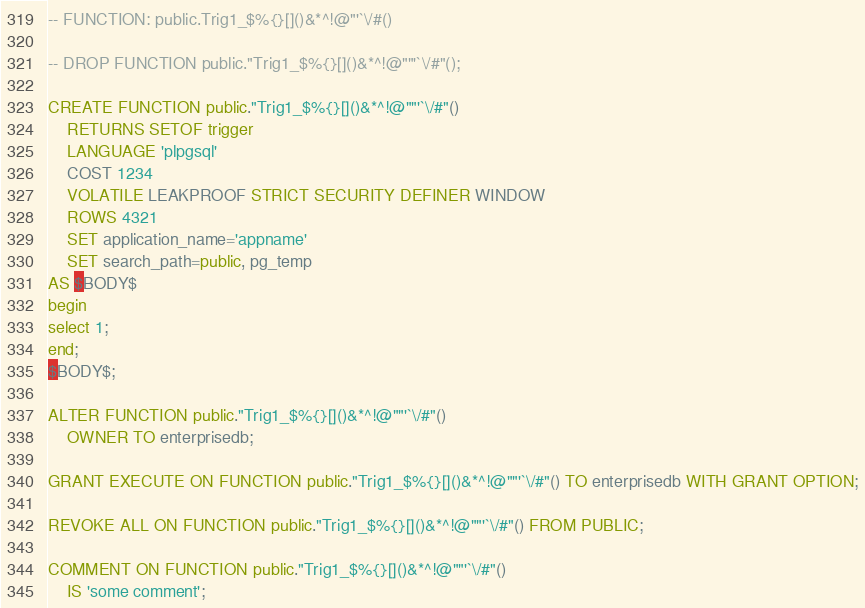<code> <loc_0><loc_0><loc_500><loc_500><_SQL_>-- FUNCTION: public.Trig1_$%{}[]()&*^!@"'`\/#()

-- DROP FUNCTION public."Trig1_$%{}[]()&*^!@""'`\/#"();

CREATE FUNCTION public."Trig1_$%{}[]()&*^!@""'`\/#"()
    RETURNS SETOF trigger
    LANGUAGE 'plpgsql'
    COST 1234
    VOLATILE LEAKPROOF STRICT SECURITY DEFINER WINDOW
    ROWS 4321
    SET application_name='appname'
    SET search_path=public, pg_temp
AS $BODY$
begin
select 1;
end;
$BODY$;

ALTER FUNCTION public."Trig1_$%{}[]()&*^!@""'`\/#"()
    OWNER TO enterprisedb;

GRANT EXECUTE ON FUNCTION public."Trig1_$%{}[]()&*^!@""'`\/#"() TO enterprisedb WITH GRANT OPTION;

REVOKE ALL ON FUNCTION public."Trig1_$%{}[]()&*^!@""'`\/#"() FROM PUBLIC;

COMMENT ON FUNCTION public."Trig1_$%{}[]()&*^!@""'`\/#"()
    IS 'some comment';
</code> 